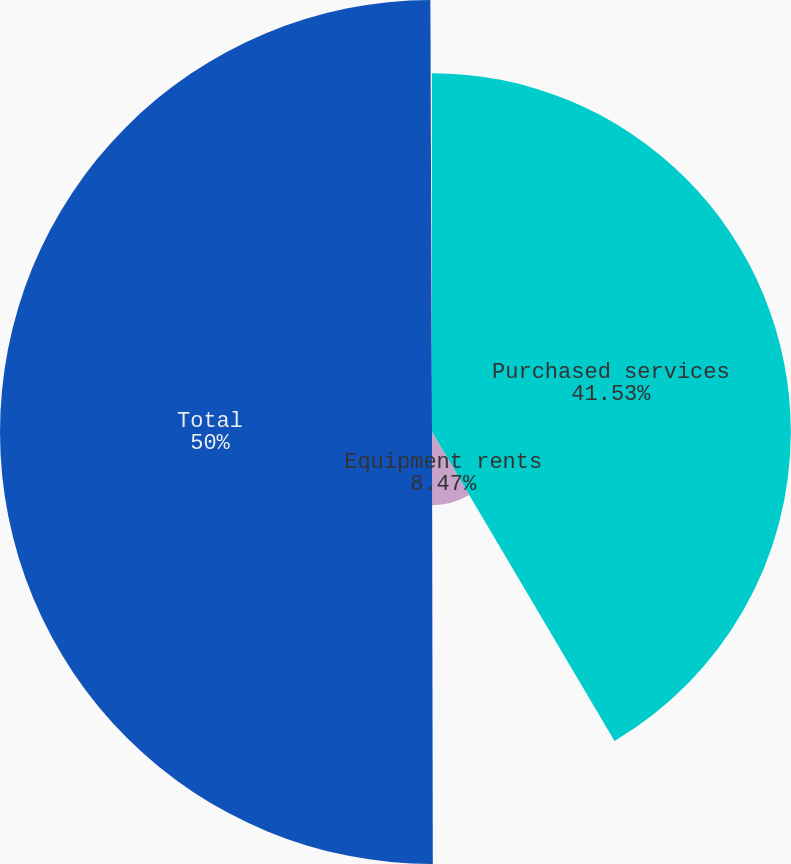Convert chart to OTSL. <chart><loc_0><loc_0><loc_500><loc_500><pie_chart><fcel>Purchased services<fcel>Equipment rents<fcel>Total<nl><fcel>41.53%<fcel>8.47%<fcel>50.0%<nl></chart> 